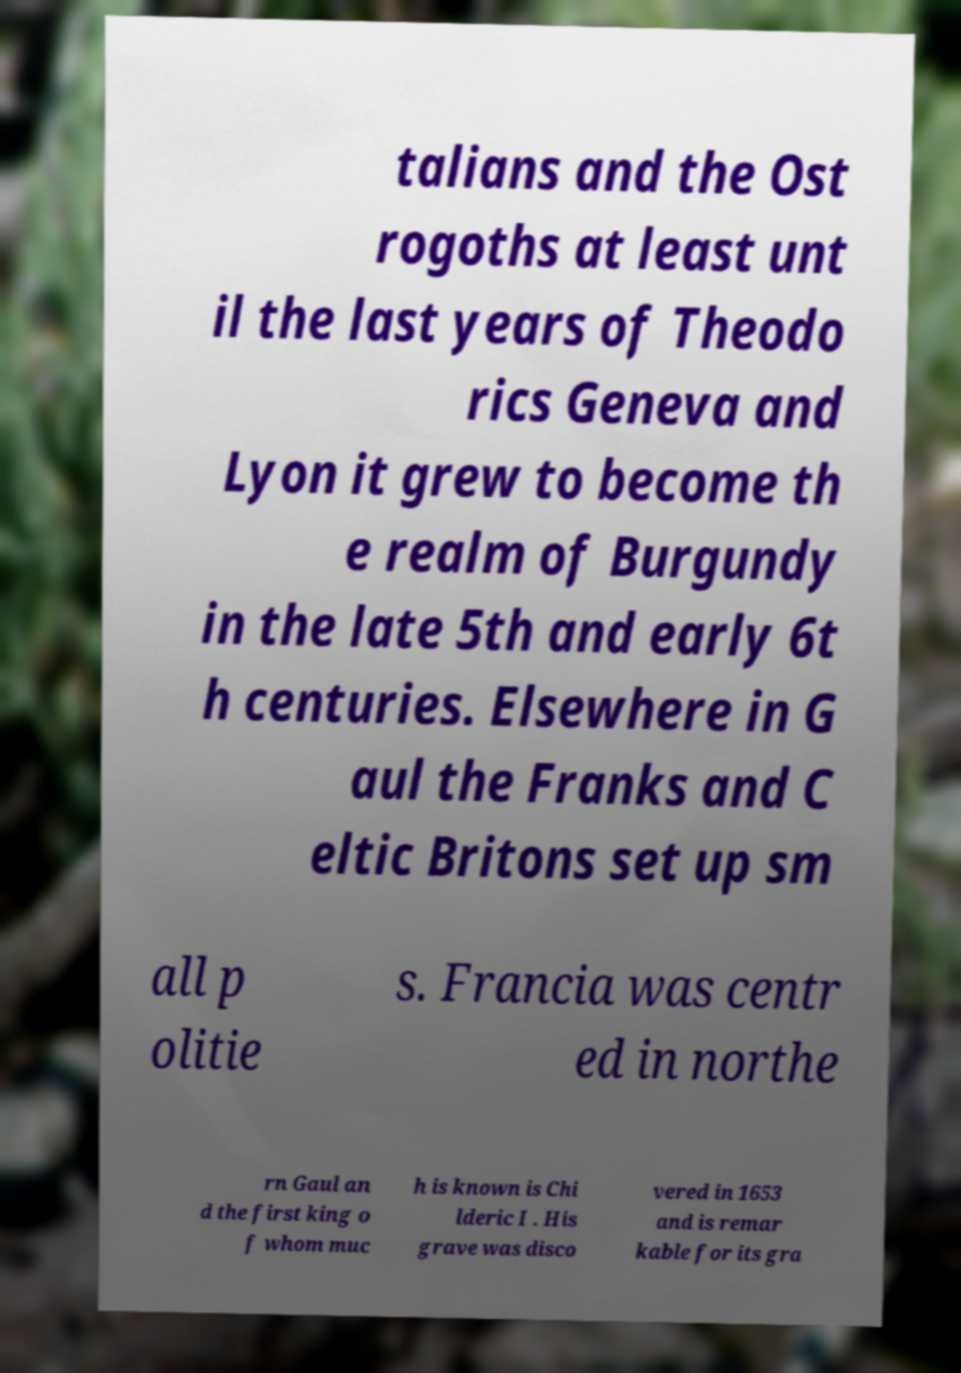Can you accurately transcribe the text from the provided image for me? talians and the Ost rogoths at least unt il the last years of Theodo rics Geneva and Lyon it grew to become th e realm of Burgundy in the late 5th and early 6t h centuries. Elsewhere in G aul the Franks and C eltic Britons set up sm all p olitie s. Francia was centr ed in northe rn Gaul an d the first king o f whom muc h is known is Chi lderic I . His grave was disco vered in 1653 and is remar kable for its gra 